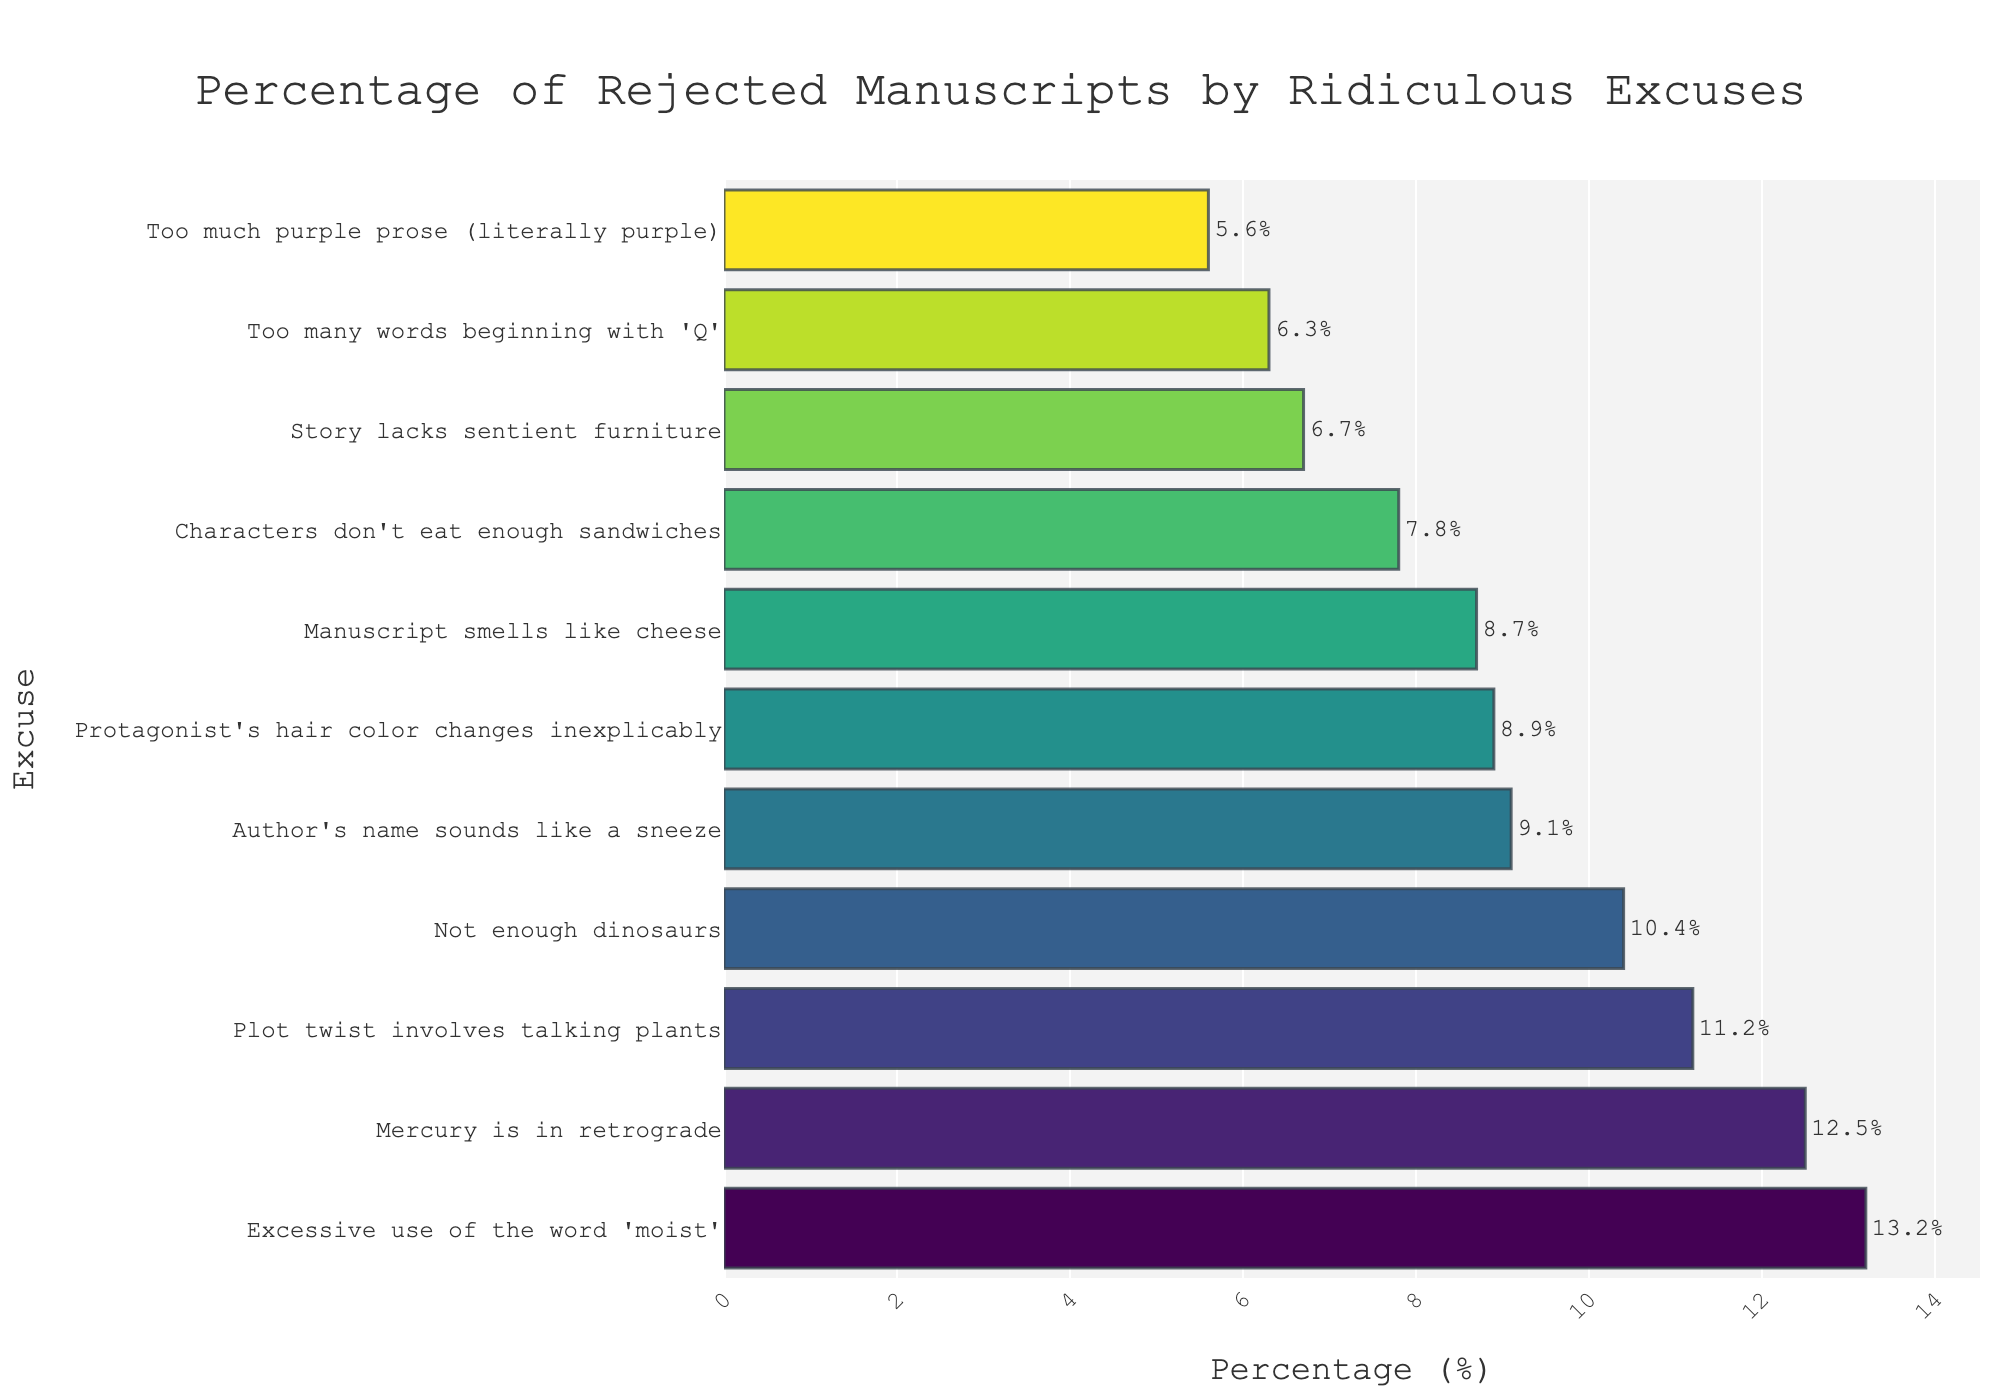What's the most common excuse for manuscript rejection? The most common excuse is the one with the highest percentage bar, which is "Excessive use of the word 'moist'" at 13.2%.
Answer: "Excessive use of the word 'moist'" What is the combined percentage of manuscripts rejected due to "Mercury is in retrograde" and "Not enough dinosaurs"? Add the percentages for "Mercury is in retrograde" (12.5%) and "Not enough dinosaurs" (10.4%): 12.5 + 10.4 = 22.9%.
Answer: 22.9% Which excuse is the least common for manuscript rejection? The least common excuse is the one with the lowest percentage bar, which is "Too much purple prose (literally purple)" at 5.6%.
Answer: "Too much purple prose (literally purple)" How much higher is the percentage of manuscripts rejected for "Protagonist's hair color changes inexplicably" than for "Too many words beginning with 'Q'"? Subtract the percentage for "Too many words beginning with 'Q'" (6.3%) from the percentage for "Protagonist's hair color changes inexplicably" (8.9%): 8.9 - 6.3 = 2.6%.
Answer: 2.6% What is the average percentage of manuscripts rejected for the excuses "Manuscript smells like cheese", "Author's name sounds like a sneeze", and "Characters don't eat enough sandwiches"? Sum the percentages and divide by three: (8.7 + 9.1 + 7.8) / 3 = 8.53%.
Answer: 8.53% Between "Plot twist involves talking plants" and "Story lacks sentient furniture", which excuse has a higher rejection percentage and by how much? Compare the percentages: "Plot twist involves talking plants" is 11.2% and "Story lacks sentient furniture" is 6.7%. Subtract the lower from the higher: 11.2 - 6.7 = 4.5%.
Answer: "Plot twist involves talking plants", 4.5% What is the median percentage of all the rejection excuses? Arrange the percentages in ascending order and find the middle value: 5.6, 6.3, 6.7, 7.8, 8.7, 8.9, 9.1, 10.4, 11.2, 12.5, 13.2. The median, being the 6th value, is 8.9%.
Answer: 8.9% What is the total percentage of manuscripts rejected due to reasons related to characters (if any)? Sum the percentages of the excuses directly mentioning characters: "Characters don't eat enough sandwiches" (7.8%) and "Protagonist's hair color changes inexplicably" (8.9%): 7.8 + 8.9 = 16.7%.
Answer: 16.7% 